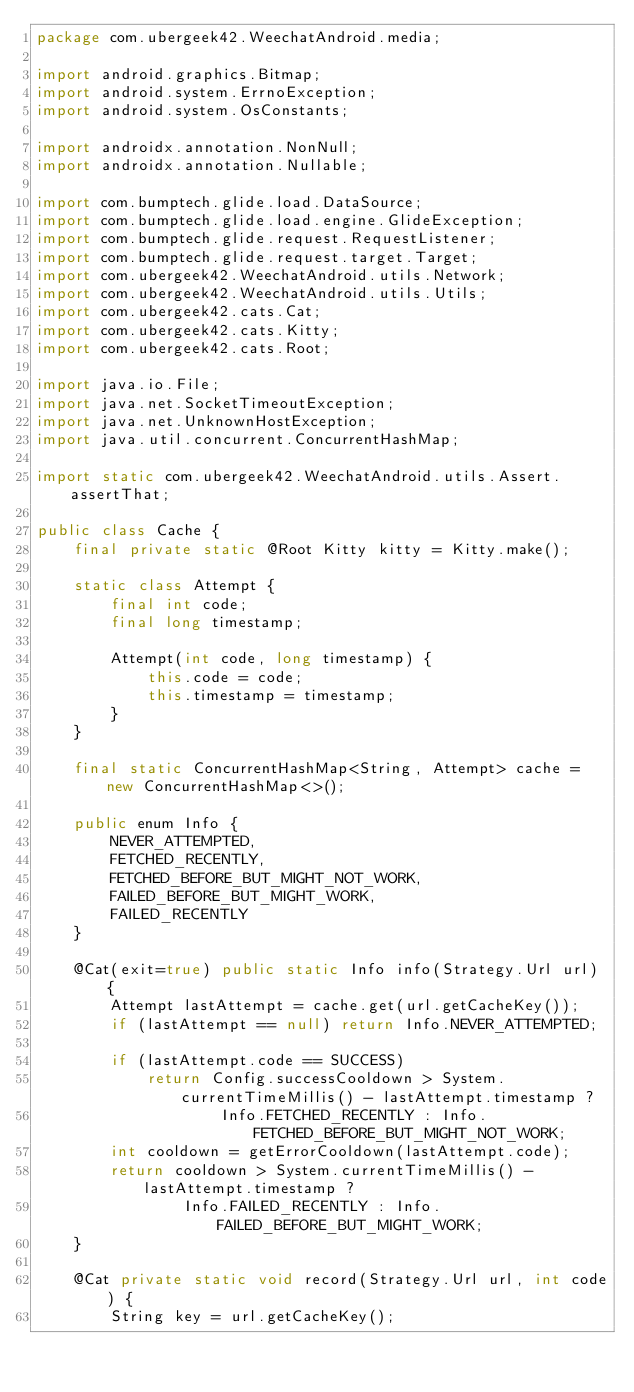<code> <loc_0><loc_0><loc_500><loc_500><_Java_>package com.ubergeek42.WeechatAndroid.media;

import android.graphics.Bitmap;
import android.system.ErrnoException;
import android.system.OsConstants;

import androidx.annotation.NonNull;
import androidx.annotation.Nullable;

import com.bumptech.glide.load.DataSource;
import com.bumptech.glide.load.engine.GlideException;
import com.bumptech.glide.request.RequestListener;
import com.bumptech.glide.request.target.Target;
import com.ubergeek42.WeechatAndroid.utils.Network;
import com.ubergeek42.WeechatAndroid.utils.Utils;
import com.ubergeek42.cats.Cat;
import com.ubergeek42.cats.Kitty;
import com.ubergeek42.cats.Root;

import java.io.File;
import java.net.SocketTimeoutException;
import java.net.UnknownHostException;
import java.util.concurrent.ConcurrentHashMap;

import static com.ubergeek42.WeechatAndroid.utils.Assert.assertThat;

public class Cache {
    final private static @Root Kitty kitty = Kitty.make();

    static class Attempt {
        final int code;
        final long timestamp;

        Attempt(int code, long timestamp) {
            this.code = code;
            this.timestamp = timestamp;
        }
    }

    final static ConcurrentHashMap<String, Attempt> cache = new ConcurrentHashMap<>();

    public enum Info {
        NEVER_ATTEMPTED,
        FETCHED_RECENTLY,
        FETCHED_BEFORE_BUT_MIGHT_NOT_WORK,
        FAILED_BEFORE_BUT_MIGHT_WORK,
        FAILED_RECENTLY
    }

    @Cat(exit=true) public static Info info(Strategy.Url url) {
        Attempt lastAttempt = cache.get(url.getCacheKey());
        if (lastAttempt == null) return Info.NEVER_ATTEMPTED;

        if (lastAttempt.code == SUCCESS)
            return Config.successCooldown > System.currentTimeMillis() - lastAttempt.timestamp ?
                    Info.FETCHED_RECENTLY : Info.FETCHED_BEFORE_BUT_MIGHT_NOT_WORK;
        int cooldown = getErrorCooldown(lastAttempt.code);
        return cooldown > System.currentTimeMillis() - lastAttempt.timestamp ?
                Info.FAILED_RECENTLY : Info.FAILED_BEFORE_BUT_MIGHT_WORK;
    }

    @Cat private static void record(Strategy.Url url, int code) {
        String key = url.getCacheKey();</code> 